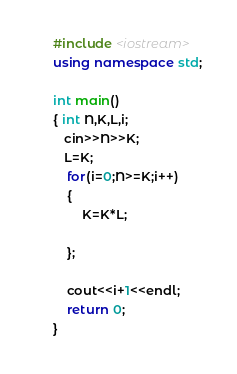<code> <loc_0><loc_0><loc_500><loc_500><_C++_>#include <iostream>
using namespace std;
 
int main()
{ int N,K,L,i;
   cin>>N>>K;
   L=K;
    for(i=0;N>=K;i++)
    {
        K=K*L;
    
    };
    
    cout<<i+1<<endl;
    return 0;
}</code> 